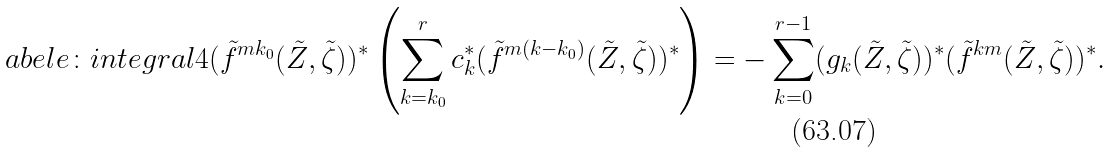Convert formula to latex. <formula><loc_0><loc_0><loc_500><loc_500>\L a b e l { e \colon i n t e g r a l 4 } ( \tilde { f } ^ { m k _ { 0 } } ( \tilde { Z } , \tilde { \zeta } ) ) ^ { * } \left ( \sum _ { k = k _ { 0 } } ^ { r } c _ { k } ^ { * } ( \tilde { f } ^ { m ( k - k _ { 0 } ) } ( \tilde { Z } , \tilde { \zeta } ) ) ^ { * } \right ) = - \sum _ { k = 0 } ^ { r - 1 } ( g _ { k } ( \tilde { Z } , \tilde { \zeta } ) ) ^ { * } ( \tilde { f } ^ { k m } ( \tilde { Z } , \tilde { \zeta } ) ) ^ { * } .</formula> 